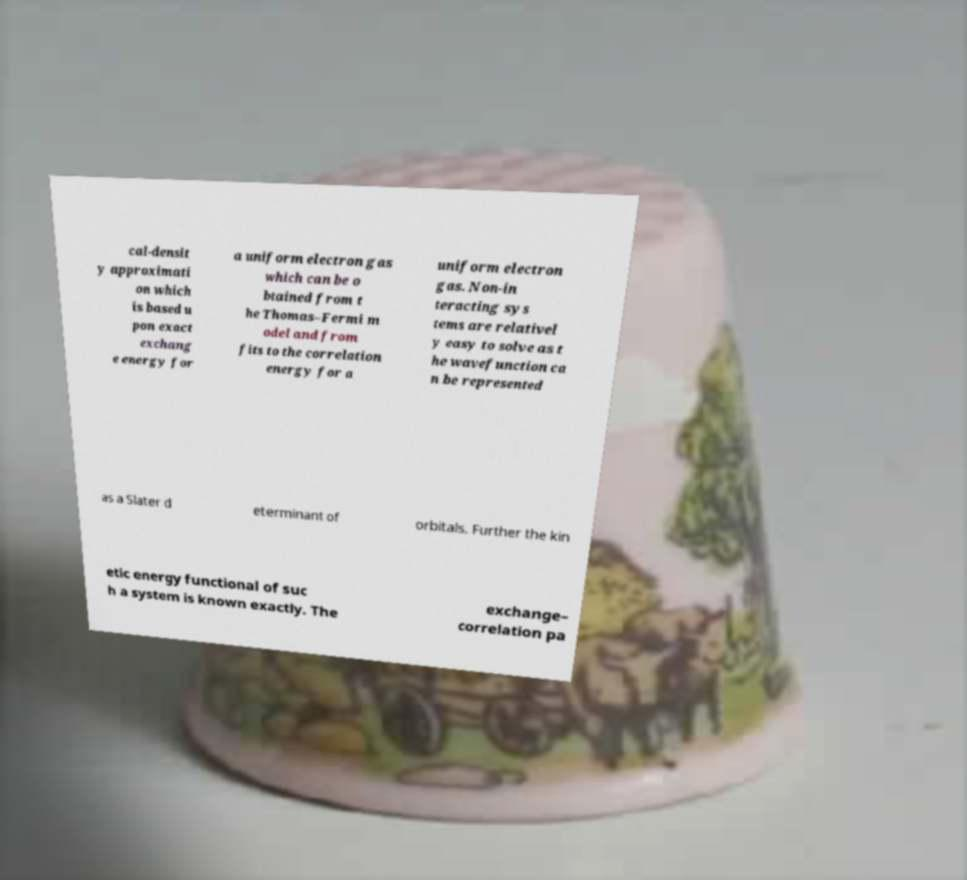I need the written content from this picture converted into text. Can you do that? cal-densit y approximati on which is based u pon exact exchang e energy for a uniform electron gas which can be o btained from t he Thomas–Fermi m odel and from fits to the correlation energy for a uniform electron gas. Non-in teracting sys tems are relativel y easy to solve as t he wavefunction ca n be represented as a Slater d eterminant of orbitals. Further the kin etic energy functional of suc h a system is known exactly. The exchange– correlation pa 